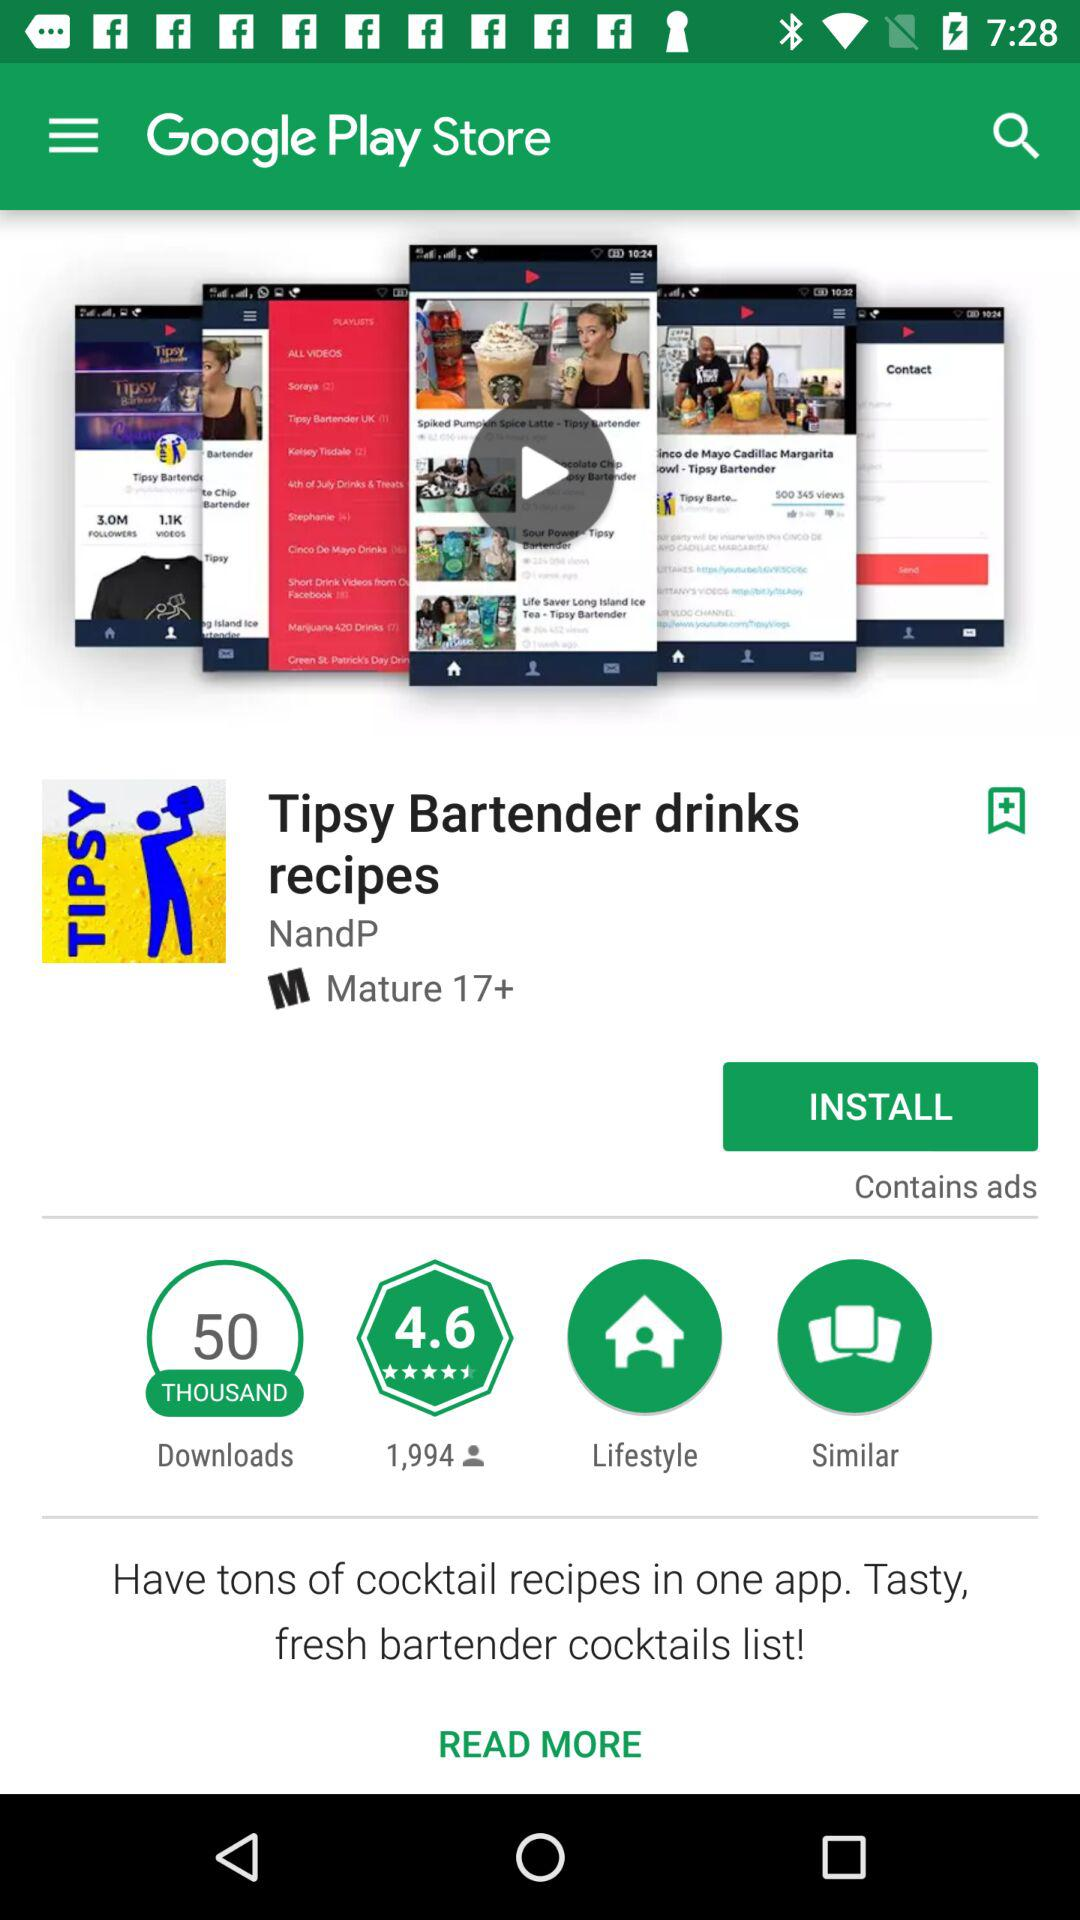How many downloads does the application "Tipsy Bartender drinks recipes" have? The application "Tipsy Bartender drinks recipes" has 50 thousand downloads. 